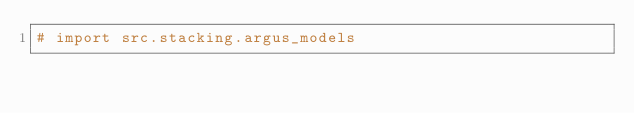<code> <loc_0><loc_0><loc_500><loc_500><_Python_># import src.stacking.argus_models
</code> 